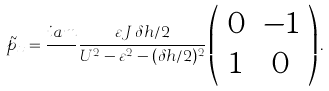<formula> <loc_0><loc_0><loc_500><loc_500>\tilde { p } _ { x } = \frac { i a m } { } \frac { \varepsilon J \, \delta h / 2 } { U ^ { 2 } - \varepsilon ^ { 2 } - ( \delta h / 2 ) ^ { 2 } } \left ( \begin{array} { c c } 0 & - 1 \\ 1 & 0 \end{array} \right ) .</formula> 